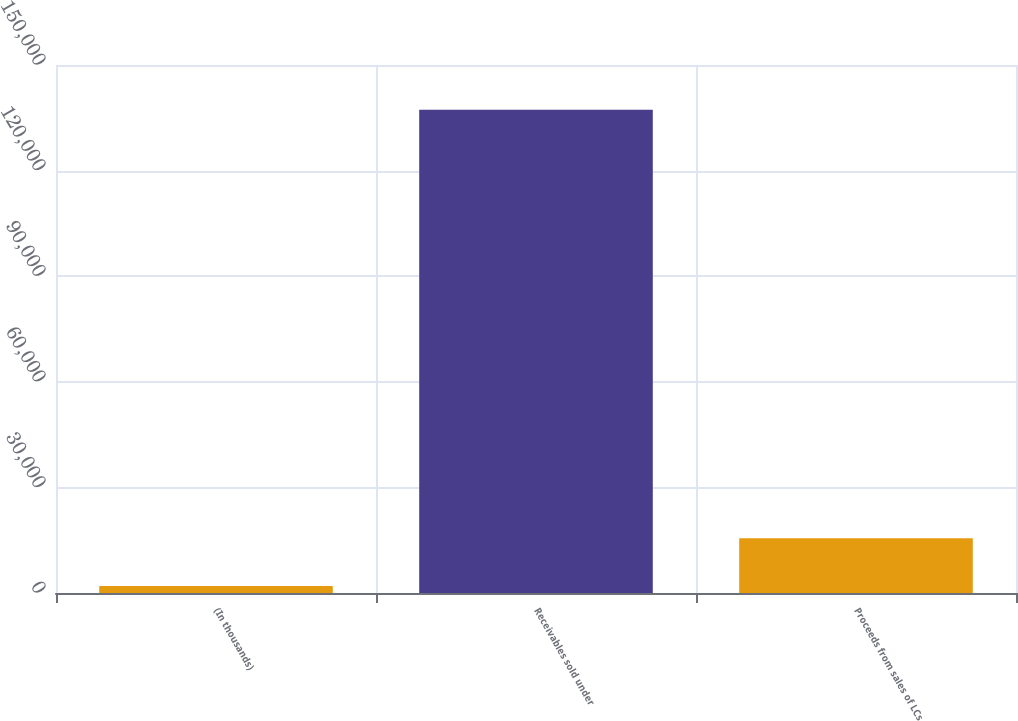Convert chart to OTSL. <chart><loc_0><loc_0><loc_500><loc_500><bar_chart><fcel>(In thousands)<fcel>Receivables sold under<fcel>Proceeds from sales of LCs<nl><fcel>2015<fcel>137285<fcel>15542<nl></chart> 